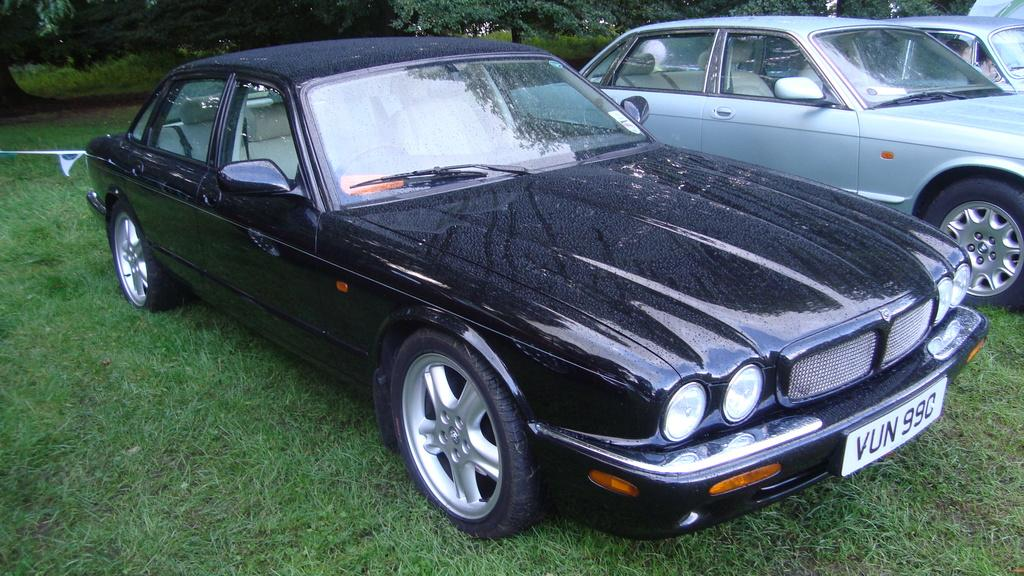What is located on the grass in the image? There are vehicles on the grass in the image. What can be seen in the image besides the vehicles? There is water visible in the image, and there are trees in the background. Can you describe the object on the left side of the image? Unfortunately, the provided facts do not give any information about the object on the left side of the image. How many people are kicking the kite in the image? There is no kite present in the image, so it is not possible to answer that question. 